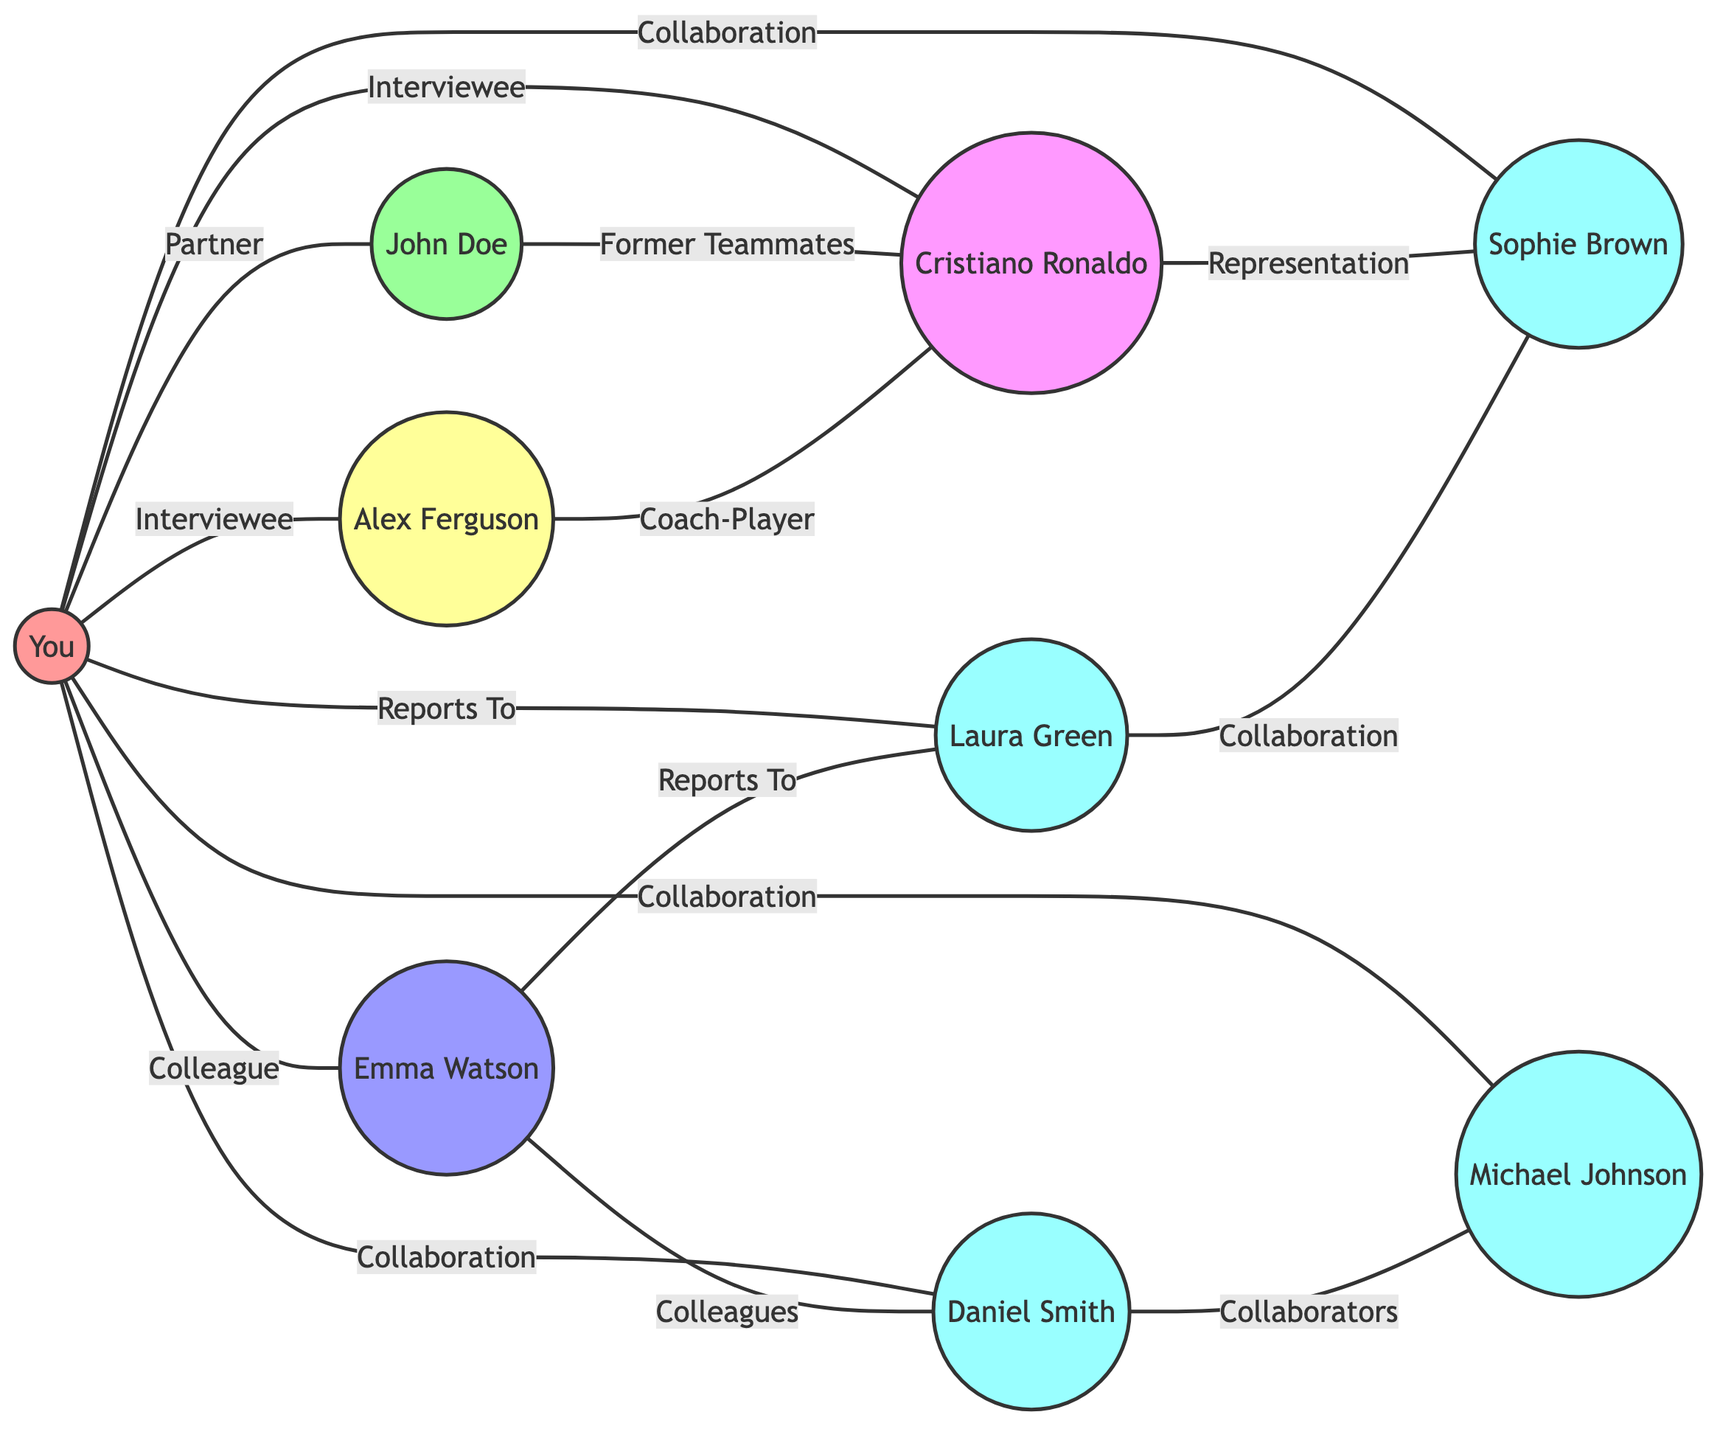What's the total number of nodes in the diagram? The diagram lists the nodes: Sports Reporter (You), Partner (John Doe), Colleague (Emma Watson), Coach (Alex Ferguson), Team Captain (Cristiano Ronaldo), Photographer (Daniel Smith), Soccer Analyst (Michael Johnson), Editor (Laura Green), and PR Manager (Sophie Brown). Counting these, we find there are a total of 9 nodes.
Answer: 9 Who is the Partner of the Sports Reporter? In the diagram, there is a direct edge connecting the Sports Reporter (You) to Partner (John Doe), labeled as "Partner," showing their relationship clearly.
Answer: John Doe Which character is listed as an Interviewee concerning the Sports Reporter? The edges indicate that both Coach (Alex Ferguson) and Team Captain (Cristiano Ronaldo) have direct connections listed as "Interviewee" to the Sports Reporter (You). This means both characters fulfill this role in relation to the Sports Reporter.
Answer: Alex Ferguson, Cristiano Ronaldo How many Professional Collaborations are shown for the Sports Reporter? The connections from the Sports Reporter (You) to Photographer (Daniel Smith), Soccer Analyst (Michael Johnson), and PR Manager (Sophie Brown) are labeled "Professional Collaboration." There are three such connections, which can be counted directly from the edges.
Answer: 3 Which node is the Sports Reporter directly reporting to? The edge from the Sports Reporter (You) to Editor (Laura Green) is indicated with the label "Reports To." This signifies that the Sports Reporter has a reporting relationship with the Editor.
Answer: Laura Green What relationship connects the Team Captain to the PR Manager? There is a direct edge between Team Captain (Cristiano Ronaldo) and PR Manager (Sophie Brown) labeled "Professional Representation." This relationship signifies how the Team Captain is represented professionally.
Answer: Professional Representation What type of relationship exists between the Coach and Team Captain? The edge between Coach (Alex Ferguson) and Team Captain (Cristiano Ronaldo) is labeled "Coach-Player," indicating their direct relationship in a sporting context.
Answer: Coach-Player How many edges are there in total in this diagram? By counting all the connections listed in the edges section, we can add them up: there are 14 edges in total that represent various relationships among the nodes.
Answer: 14 Which edges indicate collaboration? The edges indicating collaboration are those between the Sports Reporter (You) and Photographer (Daniel Smith), and the Sports Reporter (You) and Soccer Analyst (Michael Johnson), as well as the edge between Photographer (Daniel Smith) and Soccer Analyst (Michael Johnson). These are explicitly labeled with "Collaboration."
Answer: 3 